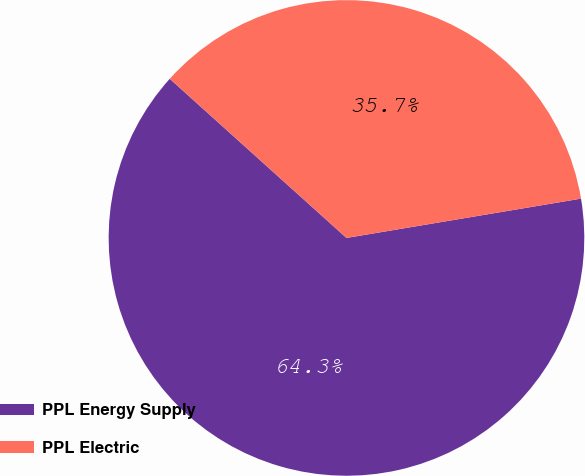Convert chart to OTSL. <chart><loc_0><loc_0><loc_500><loc_500><pie_chart><fcel>PPL Energy Supply<fcel>PPL Electric<nl><fcel>64.31%<fcel>35.69%<nl></chart> 